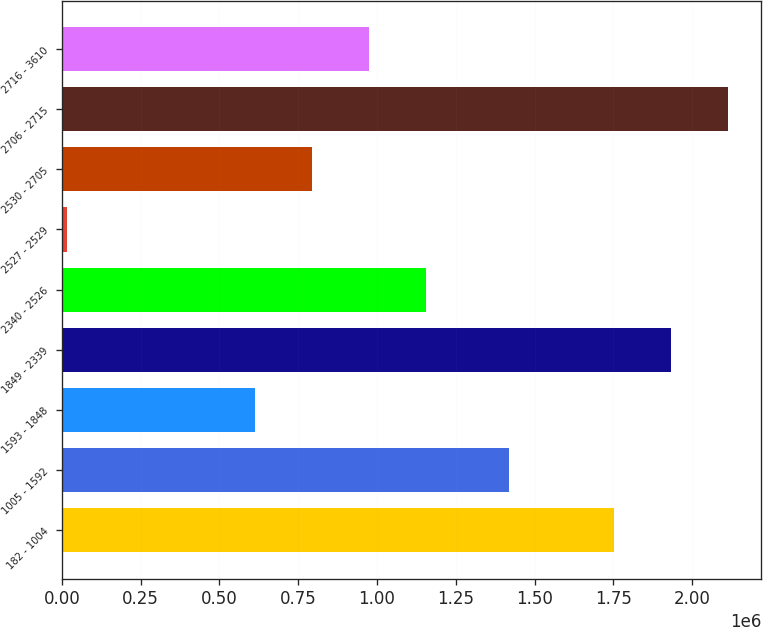Convert chart. <chart><loc_0><loc_0><loc_500><loc_500><bar_chart><fcel>182 - 1004<fcel>1005 - 1592<fcel>1593 - 1848<fcel>1849 - 2339<fcel>2340 - 2526<fcel>2527 - 2529<fcel>2530 - 2705<fcel>2706 - 2715<fcel>2716 - 3610<nl><fcel>1.75129e+06<fcel>1.41962e+06<fcel>612323<fcel>1.9319e+06<fcel>1.15417e+06<fcel>17509<fcel>792937<fcel>2.11252e+06<fcel>973551<nl></chart> 